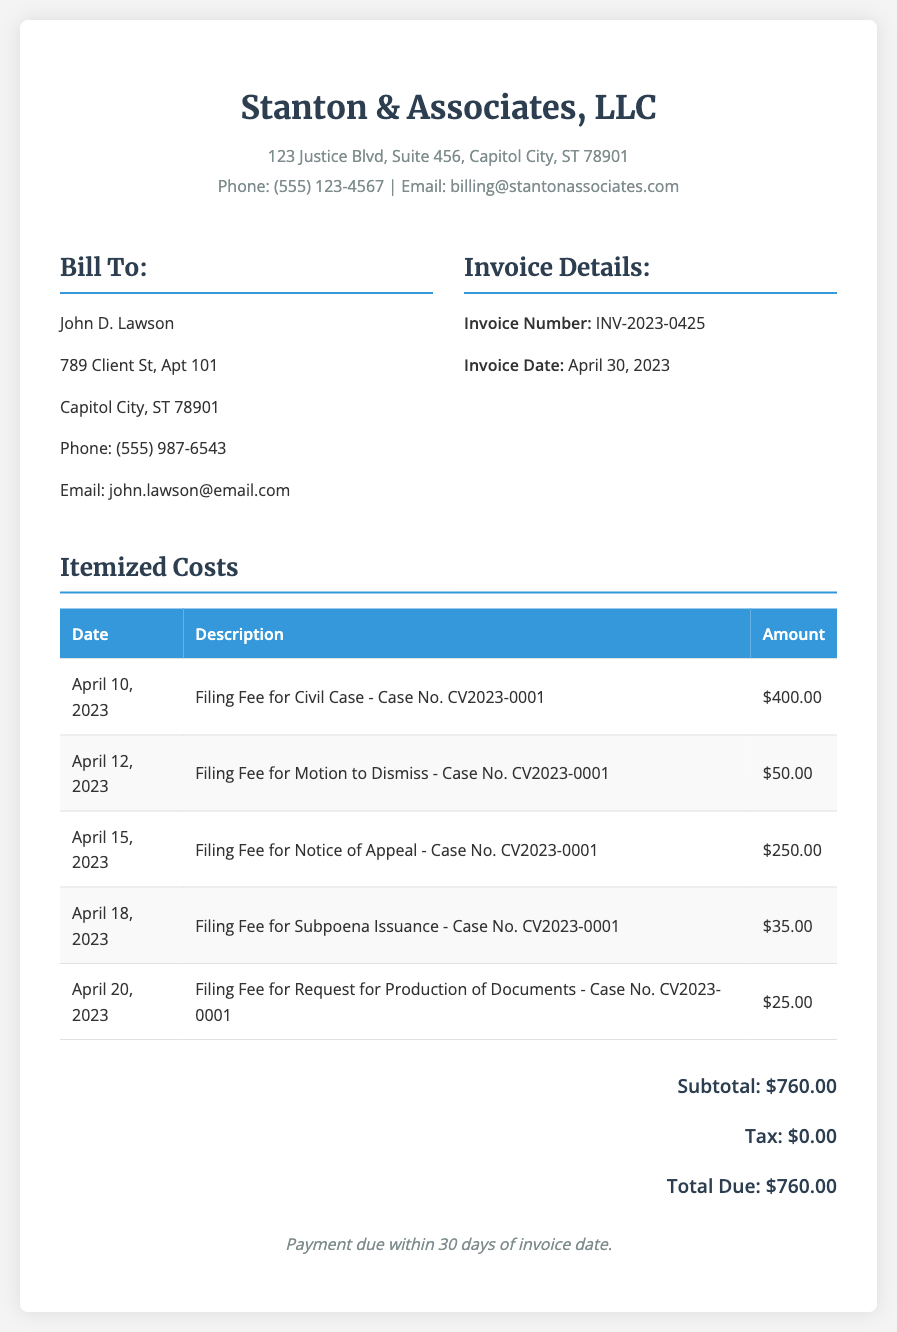What is the invoice number? The invoice number is a unique identifier assigned to the bill, which is INV-2023-0425.
Answer: INV-2023-0425 Who is billed in this invoice? The "Bill To" section contains the name of the individual being billed, which is John D. Lawson.
Answer: John D. Lawson What is the total amount due? The total due is the final amount that needs to be paid, which is $760.00.
Answer: $760.00 What is the filing fee for the Notice of Appeal? This specific fee can be found in the itemized list and is $250.00.
Answer: $250.00 When is the payment due? The document specifies that payment is due within 30 days of the invoice date.
Answer: 30 days What is the subtotal amount before tax? The subtotal is the total of all fees before any tax is applied, which is $760.00.
Answer: $760.00 How many different filings are listed in the itemized costs? The itemized costs section lists several distinct filings, totaling five.
Answer: Five What is the date of the invoice? The date for this invoice can be found in the invoice details, which is April 30, 2023.
Answer: April 30, 2023 What is the amount charged for the Subpoena Issuance? The fee for this specific filing is clearly stated, which is $35.00.
Answer: $35.00 